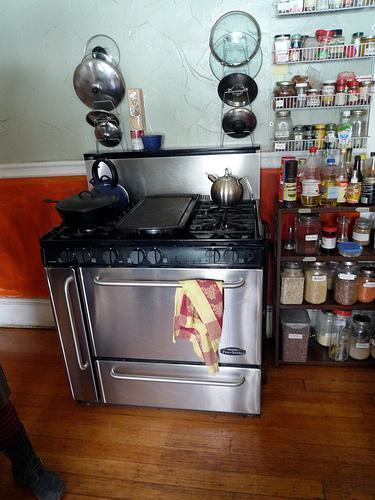What is next to the oven?
From the following set of four choices, select the accurate answer to respond to the question.
Options: Spices, refrigerator, dishwasher, sink. Spices. 